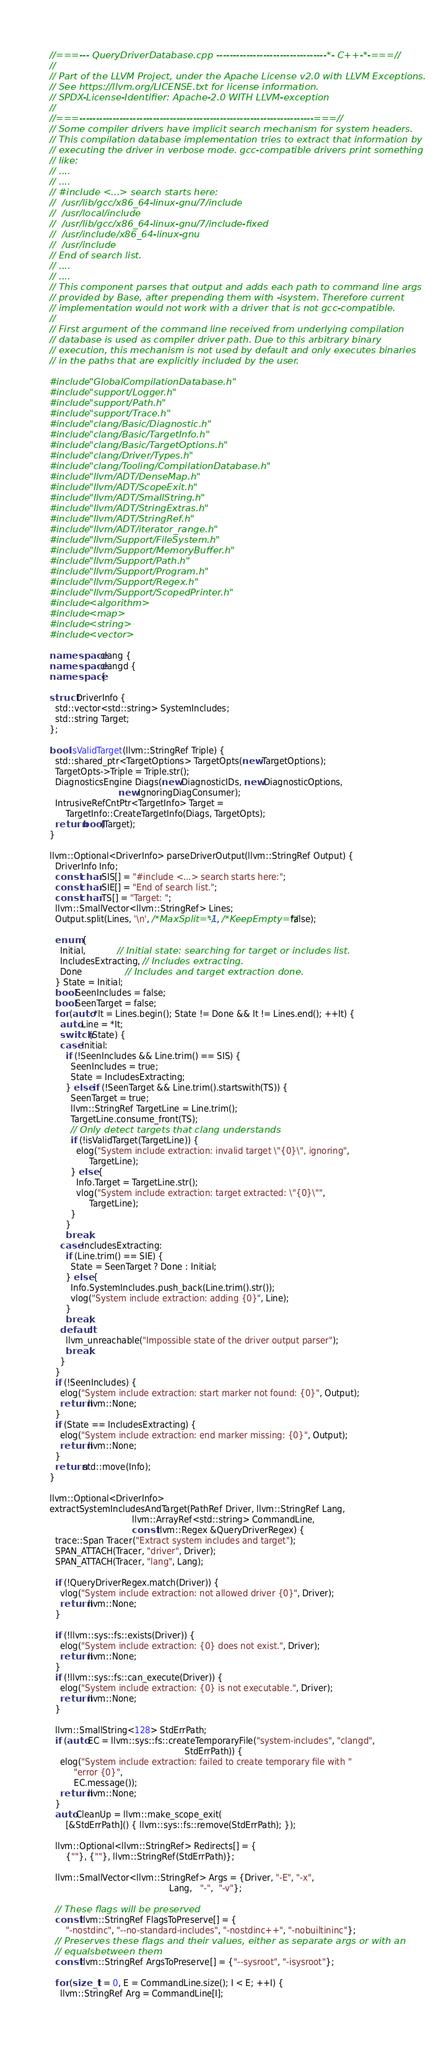Convert code to text. <code><loc_0><loc_0><loc_500><loc_500><_C++_>//===--- QueryDriverDatabase.cpp ---------------------------------*- C++-*-===//
//
// Part of the LLVM Project, under the Apache License v2.0 with LLVM Exceptions.
// See https://llvm.org/LICENSE.txt for license information.
// SPDX-License-Identifier: Apache-2.0 WITH LLVM-exception
//
//===----------------------------------------------------------------------===//
// Some compiler drivers have implicit search mechanism for system headers.
// This compilation database implementation tries to extract that information by
// executing the driver in verbose mode. gcc-compatible drivers print something
// like:
// ....
// ....
// #include <...> search starts here:
//  /usr/lib/gcc/x86_64-linux-gnu/7/include
//  /usr/local/include
//  /usr/lib/gcc/x86_64-linux-gnu/7/include-fixed
//  /usr/include/x86_64-linux-gnu
//  /usr/include
// End of search list.
// ....
// ....
// This component parses that output and adds each path to command line args
// provided by Base, after prepending them with -isystem. Therefore current
// implementation would not work with a driver that is not gcc-compatible.
//
// First argument of the command line received from underlying compilation
// database is used as compiler driver path. Due to this arbitrary binary
// execution, this mechanism is not used by default and only executes binaries
// in the paths that are explicitly included by the user.

#include "GlobalCompilationDatabase.h"
#include "support/Logger.h"
#include "support/Path.h"
#include "support/Trace.h"
#include "clang/Basic/Diagnostic.h"
#include "clang/Basic/TargetInfo.h"
#include "clang/Basic/TargetOptions.h"
#include "clang/Driver/Types.h"
#include "clang/Tooling/CompilationDatabase.h"
#include "llvm/ADT/DenseMap.h"
#include "llvm/ADT/ScopeExit.h"
#include "llvm/ADT/SmallString.h"
#include "llvm/ADT/StringExtras.h"
#include "llvm/ADT/StringRef.h"
#include "llvm/ADT/iterator_range.h"
#include "llvm/Support/FileSystem.h"
#include "llvm/Support/MemoryBuffer.h"
#include "llvm/Support/Path.h"
#include "llvm/Support/Program.h"
#include "llvm/Support/Regex.h"
#include "llvm/Support/ScopedPrinter.h"
#include <algorithm>
#include <map>
#include <string>
#include <vector>

namespace clang {
namespace clangd {
namespace {

struct DriverInfo {
  std::vector<std::string> SystemIncludes;
  std::string Target;
};

bool isValidTarget(llvm::StringRef Triple) {
  std::shared_ptr<TargetOptions> TargetOpts(new TargetOptions);
  TargetOpts->Triple = Triple.str();
  DiagnosticsEngine Diags(new DiagnosticIDs, new DiagnosticOptions,
                          new IgnoringDiagConsumer);
  IntrusiveRefCntPtr<TargetInfo> Target =
      TargetInfo::CreateTargetInfo(Diags, TargetOpts);
  return bool(Target);
}

llvm::Optional<DriverInfo> parseDriverOutput(llvm::StringRef Output) {
  DriverInfo Info;
  const char SIS[] = "#include <...> search starts here:";
  const char SIE[] = "End of search list.";
  const char TS[] = "Target: ";
  llvm::SmallVector<llvm::StringRef> Lines;
  Output.split(Lines, '\n', /*MaxSplit=*/-1, /*KeepEmpty=*/false);

  enum {
    Initial,            // Initial state: searching for target or includes list.
    IncludesExtracting, // Includes extracting.
    Done                // Includes and target extraction done.
  } State = Initial;
  bool SeenIncludes = false;
  bool SeenTarget = false;
  for (auto *It = Lines.begin(); State != Done && It != Lines.end(); ++It) {
    auto Line = *It;
    switch (State) {
    case Initial:
      if (!SeenIncludes && Line.trim() == SIS) {
        SeenIncludes = true;
        State = IncludesExtracting;
      } else if (!SeenTarget && Line.trim().startswith(TS)) {
        SeenTarget = true;
        llvm::StringRef TargetLine = Line.trim();
        TargetLine.consume_front(TS);
        // Only detect targets that clang understands
        if (!isValidTarget(TargetLine)) {
          elog("System include extraction: invalid target \"{0}\", ignoring",
               TargetLine);
        } else {
          Info.Target = TargetLine.str();
          vlog("System include extraction: target extracted: \"{0}\"",
               TargetLine);
        }
      }
      break;
    case IncludesExtracting:
      if (Line.trim() == SIE) {
        State = SeenTarget ? Done : Initial;
      } else {
        Info.SystemIncludes.push_back(Line.trim().str());
        vlog("System include extraction: adding {0}", Line);
      }
      break;
    default:
      llvm_unreachable("Impossible state of the driver output parser");
      break;
    }
  }
  if (!SeenIncludes) {
    elog("System include extraction: start marker not found: {0}", Output);
    return llvm::None;
  }
  if (State == IncludesExtracting) {
    elog("System include extraction: end marker missing: {0}", Output);
    return llvm::None;
  }
  return std::move(Info);
}

llvm::Optional<DriverInfo>
extractSystemIncludesAndTarget(PathRef Driver, llvm::StringRef Lang,
                               llvm::ArrayRef<std::string> CommandLine,
                               const llvm::Regex &QueryDriverRegex) {
  trace::Span Tracer("Extract system includes and target");
  SPAN_ATTACH(Tracer, "driver", Driver);
  SPAN_ATTACH(Tracer, "lang", Lang);

  if (!QueryDriverRegex.match(Driver)) {
    vlog("System include extraction: not allowed driver {0}", Driver);
    return llvm::None;
  }

  if (!llvm::sys::fs::exists(Driver)) {
    elog("System include extraction: {0} does not exist.", Driver);
    return llvm::None;
  }
  if (!llvm::sys::fs::can_execute(Driver)) {
    elog("System include extraction: {0} is not executable.", Driver);
    return llvm::None;
  }

  llvm::SmallString<128> StdErrPath;
  if (auto EC = llvm::sys::fs::createTemporaryFile("system-includes", "clangd",
                                                   StdErrPath)) {
    elog("System include extraction: failed to create temporary file with "
         "error {0}",
         EC.message());
    return llvm::None;
  }
  auto CleanUp = llvm::make_scope_exit(
      [&StdErrPath]() { llvm::sys::fs::remove(StdErrPath); });

  llvm::Optional<llvm::StringRef> Redirects[] = {
      {""}, {""}, llvm::StringRef(StdErrPath)};

  llvm::SmallVector<llvm::StringRef> Args = {Driver, "-E", "-x",
                                             Lang,   "-",  "-v"};

  // These flags will be preserved
  const llvm::StringRef FlagsToPreserve[] = {
      "-nostdinc", "--no-standard-includes", "-nostdinc++", "-nobuiltininc"};
  // Preserves these flags and their values, either as separate args or with an
  // equalsbetween them
  const llvm::StringRef ArgsToPreserve[] = {"--sysroot", "-isysroot"};

  for (size_t I = 0, E = CommandLine.size(); I < E; ++I) {
    llvm::StringRef Arg = CommandLine[I];</code> 